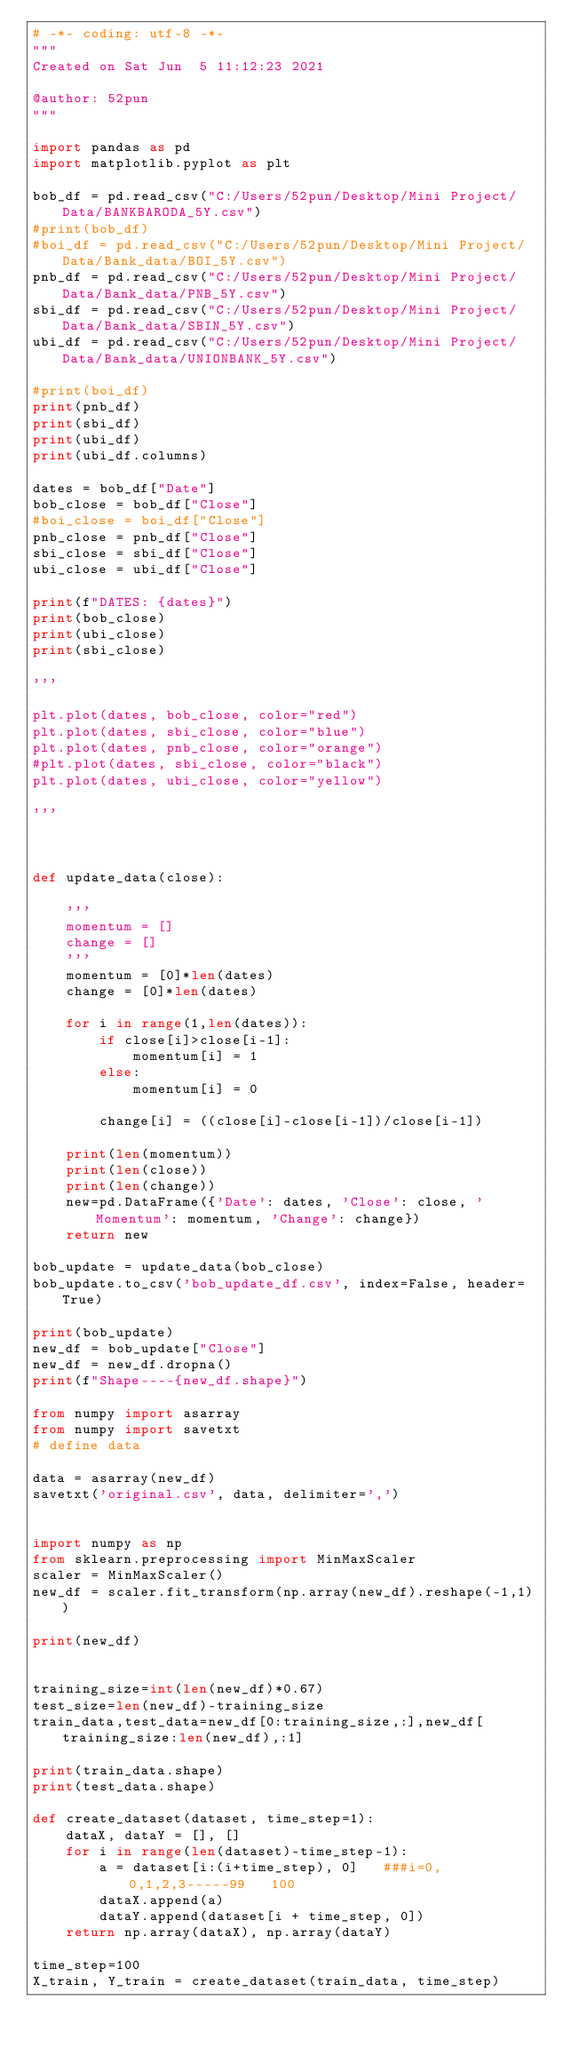Convert code to text. <code><loc_0><loc_0><loc_500><loc_500><_Python_># -*- coding: utf-8 -*-
"""
Created on Sat Jun  5 11:12:23 2021

@author: 52pun
"""

import pandas as pd
import matplotlib.pyplot as plt

bob_df = pd.read_csv("C:/Users/52pun/Desktop/Mini Project/Data/BANKBARODA_5Y.csv")
#print(bob_df)
#boi_df = pd.read_csv("C:/Users/52pun/Desktop/Mini Project/Data/Bank_data/BOI_5Y.csv")
pnb_df = pd.read_csv("C:/Users/52pun/Desktop/Mini Project/Data/Bank_data/PNB_5Y.csv")
sbi_df = pd.read_csv("C:/Users/52pun/Desktop/Mini Project/Data/Bank_data/SBIN_5Y.csv")
ubi_df = pd.read_csv("C:/Users/52pun/Desktop/Mini Project/Data/Bank_data/UNIONBANK_5Y.csv")

#print(boi_df)
print(pnb_df)
print(sbi_df)
print(ubi_df)
print(ubi_df.columns)

dates = bob_df["Date"]
bob_close = bob_df["Close"]
#boi_close = boi_df["Close"]
pnb_close = pnb_df["Close"]
sbi_close = sbi_df["Close"]
ubi_close = ubi_df["Close"]

print(f"DATES: {dates}")
print(bob_close)
print(ubi_close)
print(sbi_close)

'''

plt.plot(dates, bob_close, color="red")
plt.plot(dates, sbi_close, color="blue")
plt.plot(dates, pnb_close, color="orange")
#plt.plot(dates, sbi_close, color="black")
plt.plot(dates, ubi_close, color="yellow")

'''



def update_data(close):
    
    '''
    momentum = []
    change = []
    '''
    momentum = [0]*len(dates)
    change = [0]*len(dates)
    
    for i in range(1,len(dates)):
        if close[i]>close[i-1]:
            momentum[i] = 1
        else:
            momentum[i] = 0
        
        change[i] = ((close[i]-close[i-1])/close[i-1])
        
    print(len(momentum))
    print(len(close))
    print(len(change))
    new=pd.DataFrame({'Date': dates, 'Close': close, 'Momentum': momentum, 'Change': change})
    return new

bob_update = update_data(bob_close)
bob_update.to_csv('bob_update_df.csv', index=False, header=True)

print(bob_update)
new_df = bob_update["Close"]
new_df = new_df.dropna()
print(f"Shape----{new_df.shape}")

from numpy import asarray
from numpy import savetxt
# define data

data = asarray(new_df)
savetxt('original.csv', data, delimiter=',')


import numpy as np
from sklearn.preprocessing import MinMaxScaler
scaler = MinMaxScaler()
new_df = scaler.fit_transform(np.array(new_df).reshape(-1,1))

print(new_df)


training_size=int(len(new_df)*0.67)
test_size=len(new_df)-training_size
train_data,test_data=new_df[0:training_size,:],new_df[training_size:len(new_df),:1]

print(train_data.shape)
print(test_data.shape)

def create_dataset(dataset, time_step=1):
	dataX, dataY = [], []
	for i in range(len(dataset)-time_step-1):
		a = dataset[i:(i+time_step), 0]   ###i=0, 0,1,2,3-----99   100 
		dataX.append(a)
		dataY.append(dataset[i + time_step, 0])
	return np.array(dataX), np.array(dataY)

time_step=100
X_train, Y_train = create_dataset(train_data, time_step)</code> 